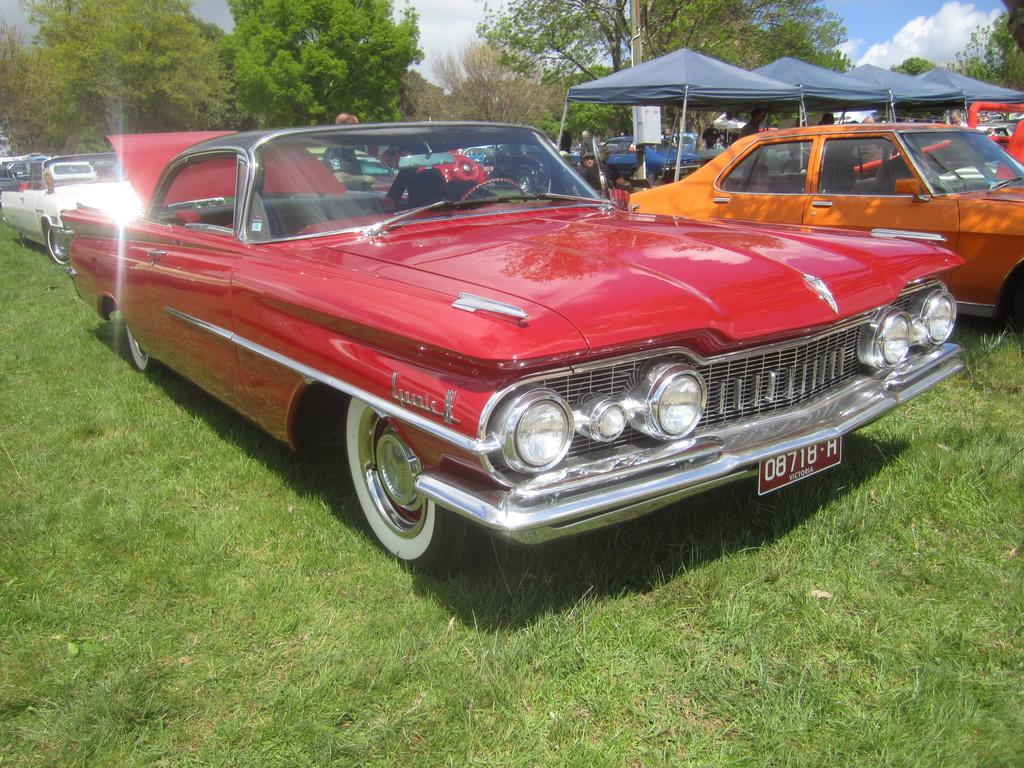What is the unusual location of the cars in the image? The cars are on the grass in the image. What can be seen in the background of the image? There is a group of people, chairs, tents, and trees in the background of the image. Where is the playground located in the image? There is no playground present in the image. Can you see any giraffes or ducks in the image? No, there are no giraffes or ducks present in the image. 